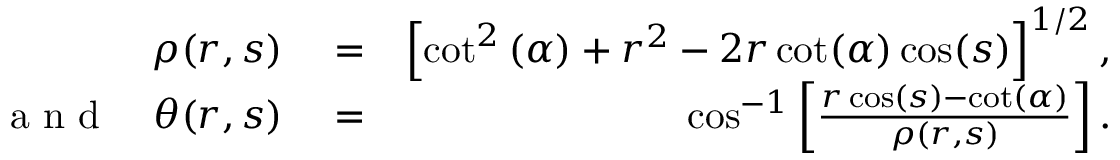Convert formula to latex. <formula><loc_0><loc_0><loc_500><loc_500>\begin{array} { r l r } { \rho ( r , s ) } & = } & { \left [ \cot ^ { 2 } \left ( \alpha \right ) + r ^ { 2 } - 2 r \cot ( \alpha ) \cos ( s ) \right ] ^ { 1 / 2 } , } \\ { a n d \quad \theta ( r , s ) } & = } & { \cos ^ { - 1 } \left [ \frac { r \cos ( s ) - \cot ( \alpha ) } { \rho ( r , s ) } \right ] . } \end{array}</formula> 